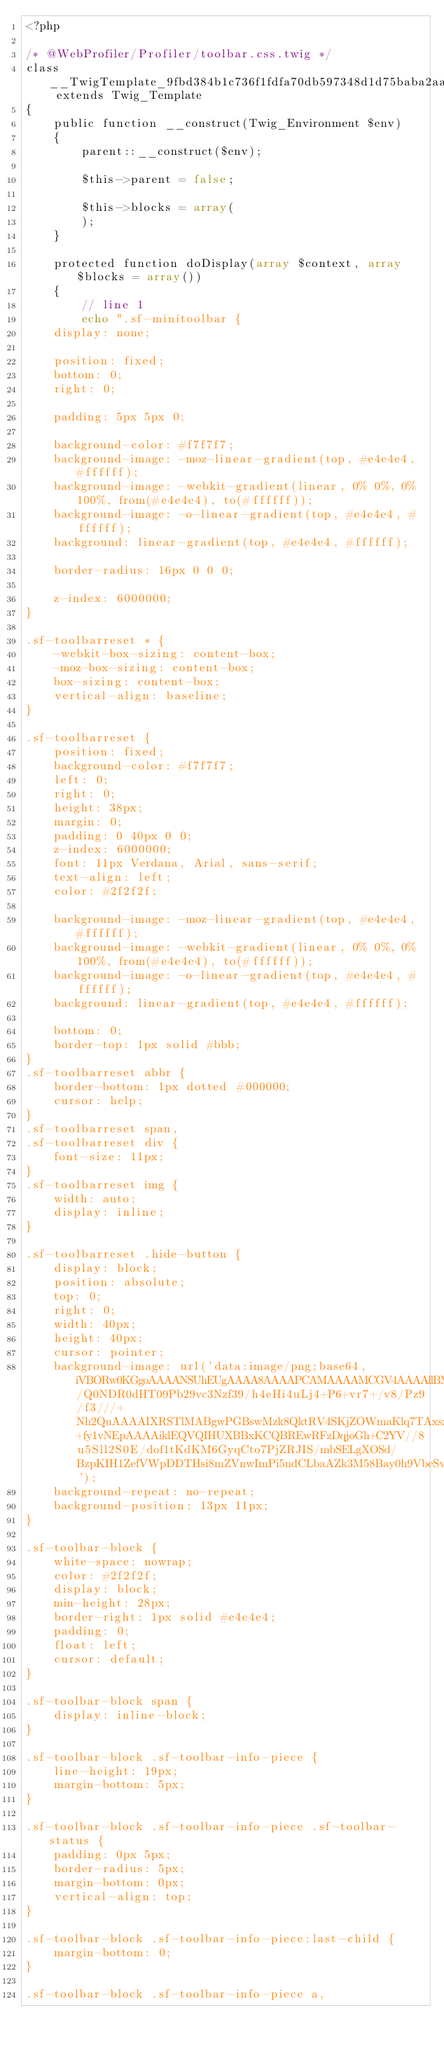<code> <loc_0><loc_0><loc_500><loc_500><_PHP_><?php

/* @WebProfiler/Profiler/toolbar.css.twig */
class __TwigTemplate_9fbd384b1c736f1fdfa70db597348d1d75baba2aa11adfc657979132f9de374c extends Twig_Template
{
    public function __construct(Twig_Environment $env)
    {
        parent::__construct($env);

        $this->parent = false;

        $this->blocks = array(
        );
    }

    protected function doDisplay(array $context, array $blocks = array())
    {
        // line 1
        echo ".sf-minitoolbar {
    display: none;

    position: fixed;
    bottom: 0;
    right: 0;

    padding: 5px 5px 0;

    background-color: #f7f7f7;
    background-image: -moz-linear-gradient(top, #e4e4e4, #ffffff);
    background-image: -webkit-gradient(linear, 0% 0%, 0% 100%, from(#e4e4e4), to(#ffffff));
    background-image: -o-linear-gradient(top, #e4e4e4, #ffffff);
    background: linear-gradient(top, #e4e4e4, #ffffff);

    border-radius: 16px 0 0 0;

    z-index: 6000000;
}

.sf-toolbarreset * {
    -webkit-box-sizing: content-box;
    -moz-box-sizing: content-box;
    box-sizing: content-box;
    vertical-align: baseline;
}

.sf-toolbarreset {
    position: fixed;
    background-color: #f7f7f7;
    left: 0;
    right: 0;
    height: 38px;
    margin: 0;
    padding: 0 40px 0 0;
    z-index: 6000000;
    font: 11px Verdana, Arial, sans-serif;
    text-align: left;
    color: #2f2f2f;

    background-image: -moz-linear-gradient(top, #e4e4e4, #ffffff);
    background-image: -webkit-gradient(linear, 0% 0%, 0% 100%, from(#e4e4e4), to(#ffffff));
    background-image: -o-linear-gradient(top, #e4e4e4, #ffffff);
    background: linear-gradient(top, #e4e4e4, #ffffff);

    bottom: 0;
    border-top: 1px solid #bbb;
}
.sf-toolbarreset abbr {
    border-bottom: 1px dotted #000000;
    cursor: help;
}
.sf-toolbarreset span,
.sf-toolbarreset div {
    font-size: 11px;
}
.sf-toolbarreset img {
    width: auto;
    display: inline;
}

.sf-toolbarreset .hide-button {
    display: block;
    position: absolute;
    top: 0;
    right: 0;
    width: 40px;
    height: 40px;
    cursor: pointer;
    background-image: url('data:image/png;base64,iVBORw0KGgoAAAANSUhEUgAAAA8AAAAPCAMAAAAMCGV4AAAAllBMVEXDw8PDw8PDw8PDw8PDw8PDw8PDw8PDw8PDw8PDw8PDw8PDw8PDw8PDw8PDw8PDw8PDw8PDw8PDw8PDw8PDw8PDw8PDw8PDw8PDw8PDw8PDw8PDw8PDw8PDw8PDw8PDw8PDw8PDw8PExMTPz8/Q0NDR0dHT09Pb29vc3Nzf39/h4eHi4uLj4+P6+vr7+/v8/Pz9/f3///+Nh2QuAAAAIXRSTlMABgwPGBswMzk8QktRV4SKjZOWmaKlq7TAxszb3urt+fy1vNEpAAAAiklEQVQIHUXBBxKCQBREwRFzDqjoGh+C2YV//8u5Sll2S0E/dof1tKdKM6GyqCto7PjZRJIS/mbSELgXOSd/BzpKIH1ZefVWpDDTHsi8mZVnwImPi5ndCLbaAZk3M58Bay0h9VbeSvMpjDUAHj4jL55AW1rxN5fU2PLjIgVRzNdxVFOlGzvnJi0Fb1XNGBHA9uQOAAAAAElFTkSuQmCC');
    background-repeat: no-repeat;
    background-position: 13px 11px;
}

.sf-toolbar-block {
    white-space: nowrap;
    color: #2f2f2f;
    display: block;
    min-height: 28px;
    border-right: 1px solid #e4e4e4;
    padding: 0;
    float: left;
    cursor: default;
}

.sf-toolbar-block span {
    display: inline-block;
}

.sf-toolbar-block .sf-toolbar-info-piece {
    line-height: 19px;
    margin-bottom: 5px;
}

.sf-toolbar-block .sf-toolbar-info-piece .sf-toolbar-status {
    padding: 0px 5px;
    border-radius: 5px;
    margin-bottom: 0px;
    vertical-align: top;
}

.sf-toolbar-block .sf-toolbar-info-piece:last-child {
    margin-bottom: 0;
}

.sf-toolbar-block .sf-toolbar-info-piece a,</code> 